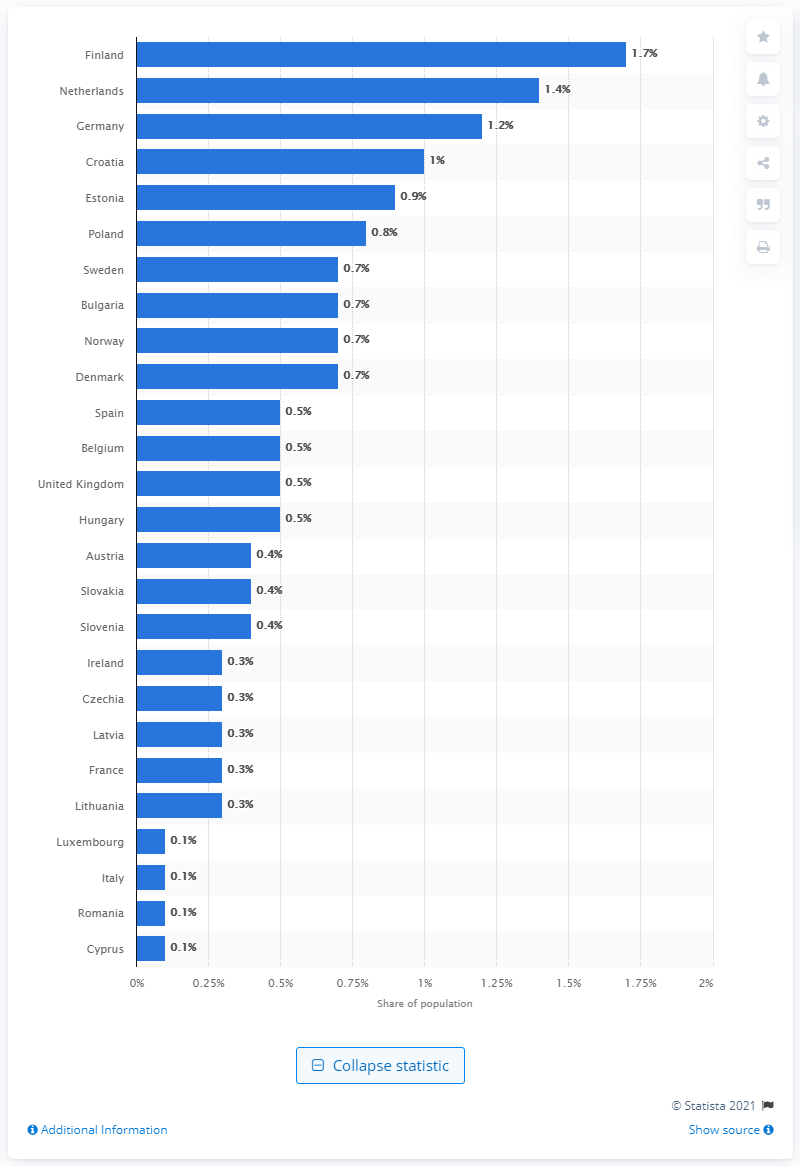Outline some significant characteristics in this image. According to a recent study, Finland had the highest prevalence of amphetamine use among adults in Europe in 2019. 